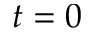Convert formula to latex. <formula><loc_0><loc_0><loc_500><loc_500>t = 0</formula> 